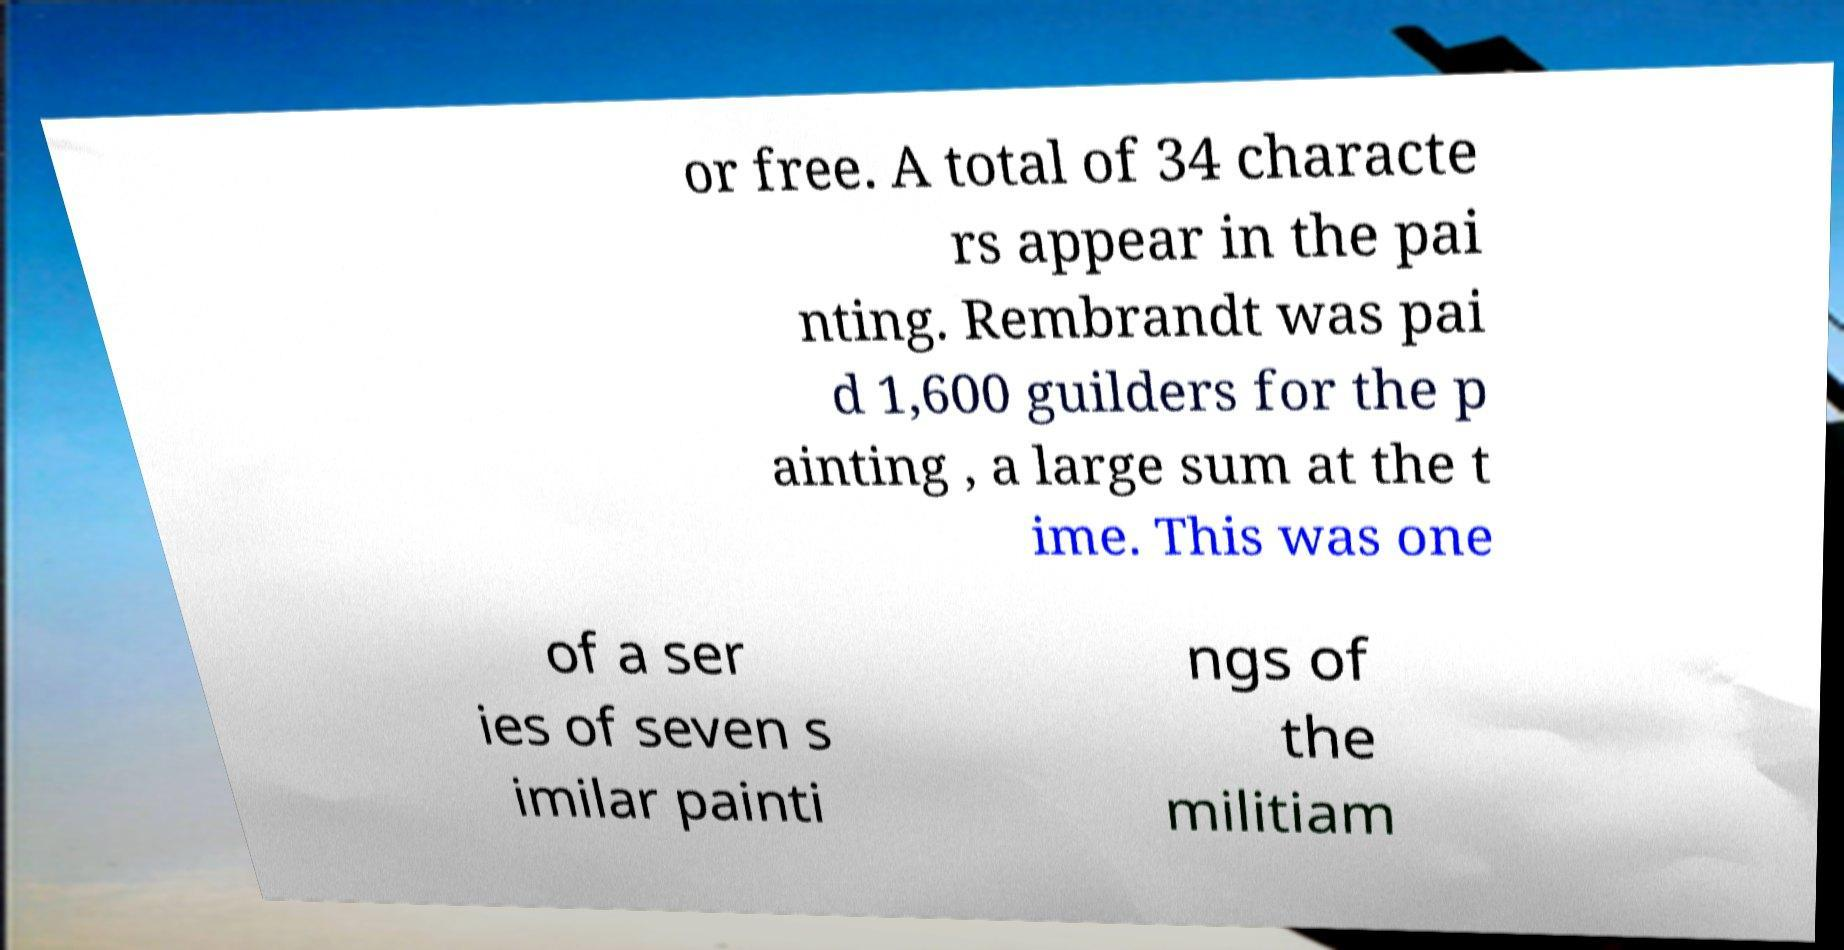Can you read and provide the text displayed in the image?This photo seems to have some interesting text. Can you extract and type it out for me? or free. A total of 34 characte rs appear in the pai nting. Rembrandt was pai d 1,600 guilders for the p ainting , a large sum at the t ime. This was one of a ser ies of seven s imilar painti ngs of the militiam 